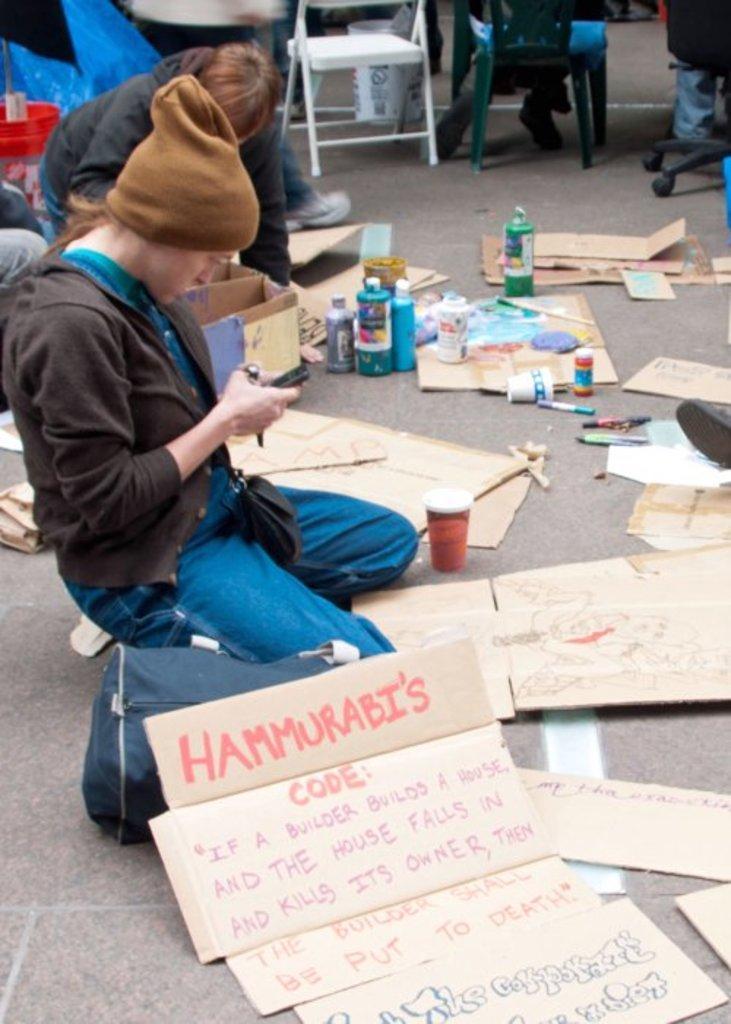Can you describe this image briefly? In this image, we can see people and one of them is wearing a cap and holding an object and we can see chairs, bottles, cardboards, markers and some other objects and a bag on the ground. 